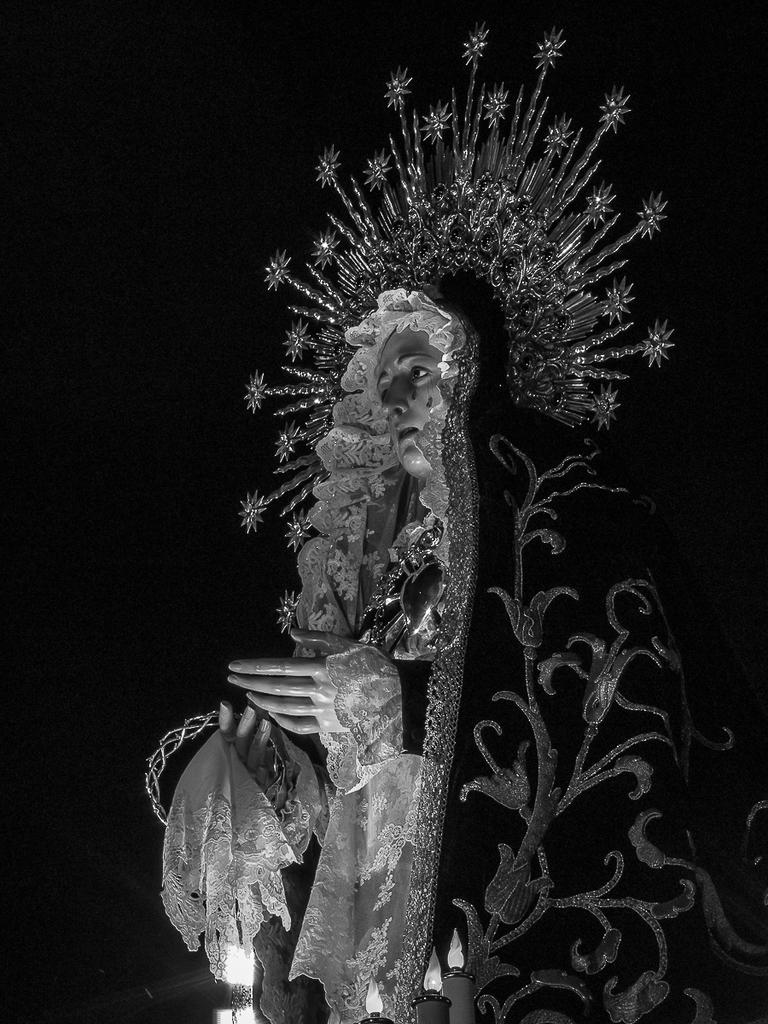What is the main subject of the image? There is a statue in the image. What is covering the statue? The statue has a cloth on it. Are there any additional features on the statue? Yes, there are lights on top of the statue. What type of flowers are growing around the base of the statue in the image? There are no flowers present in the image; it only features a statue with a cloth and lights. 